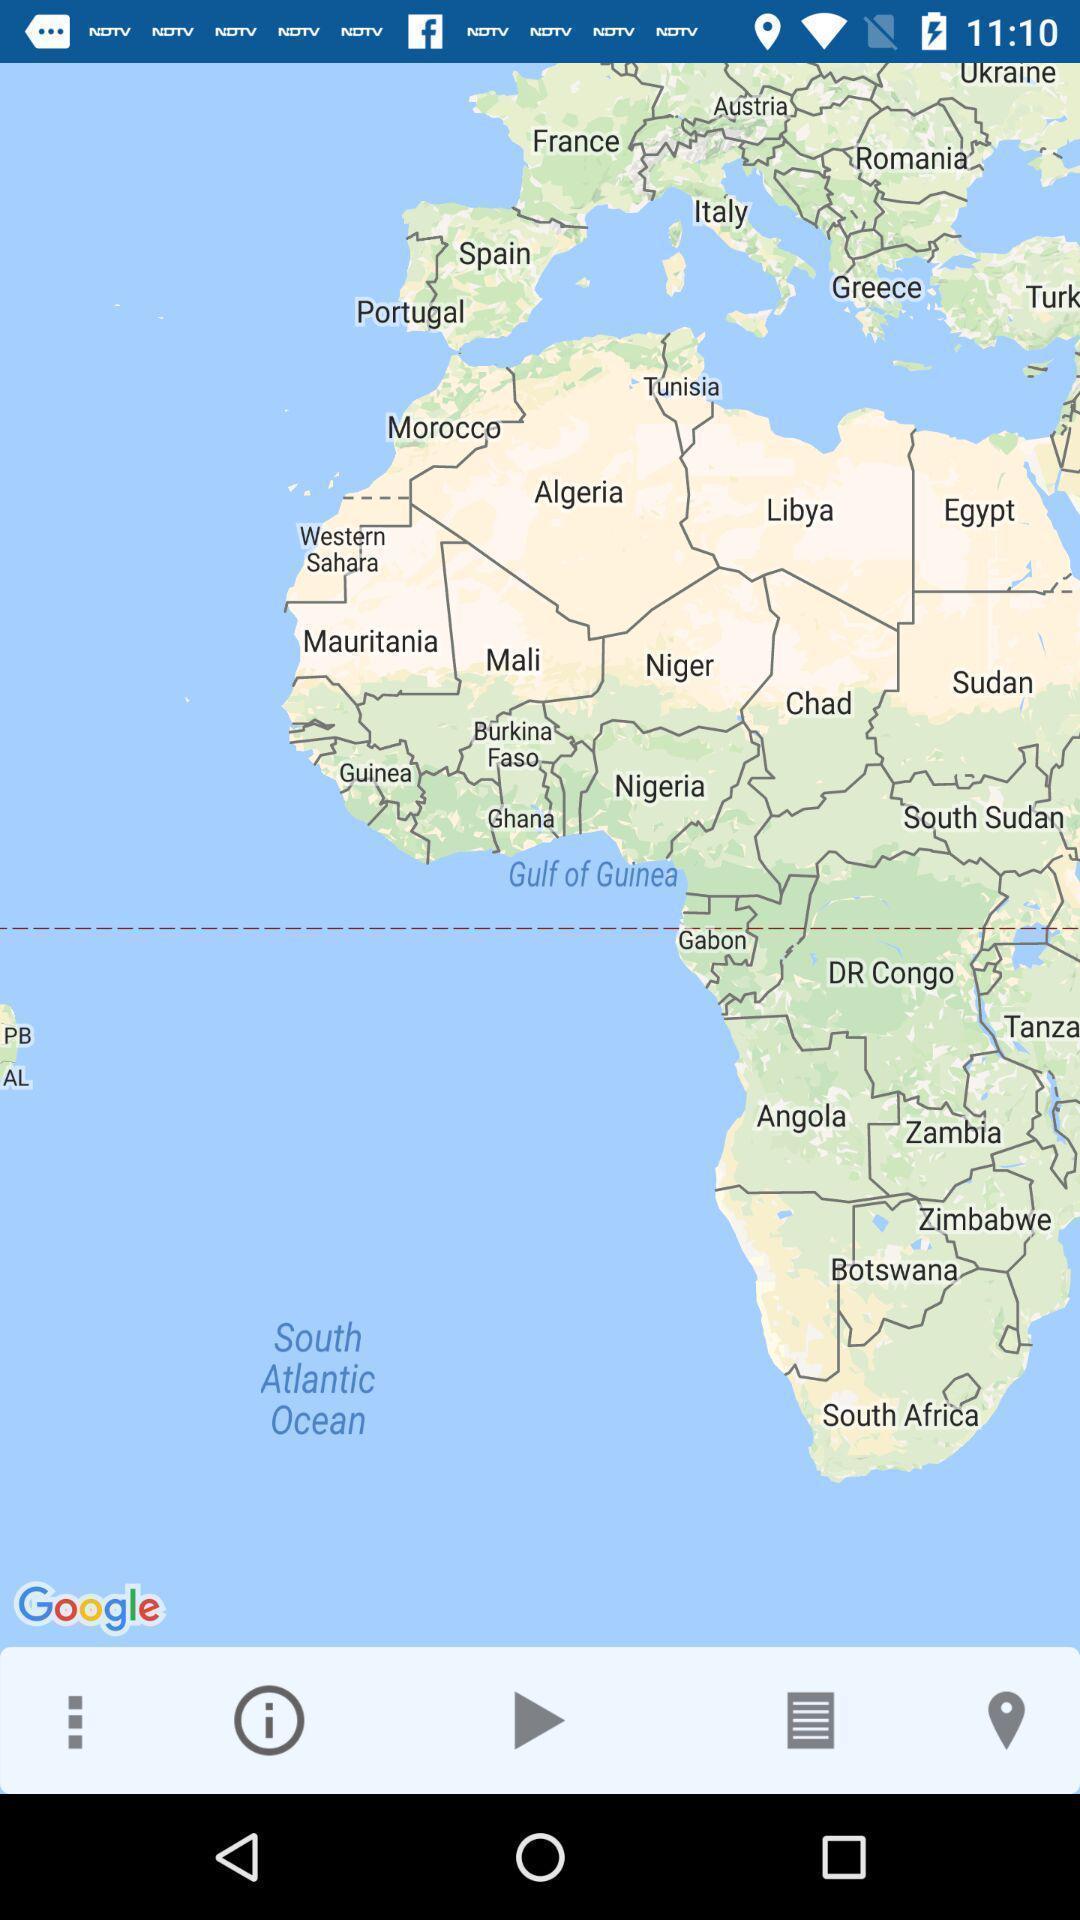Describe the visual elements of this screenshot. Screen shows map view in a navigation app. 